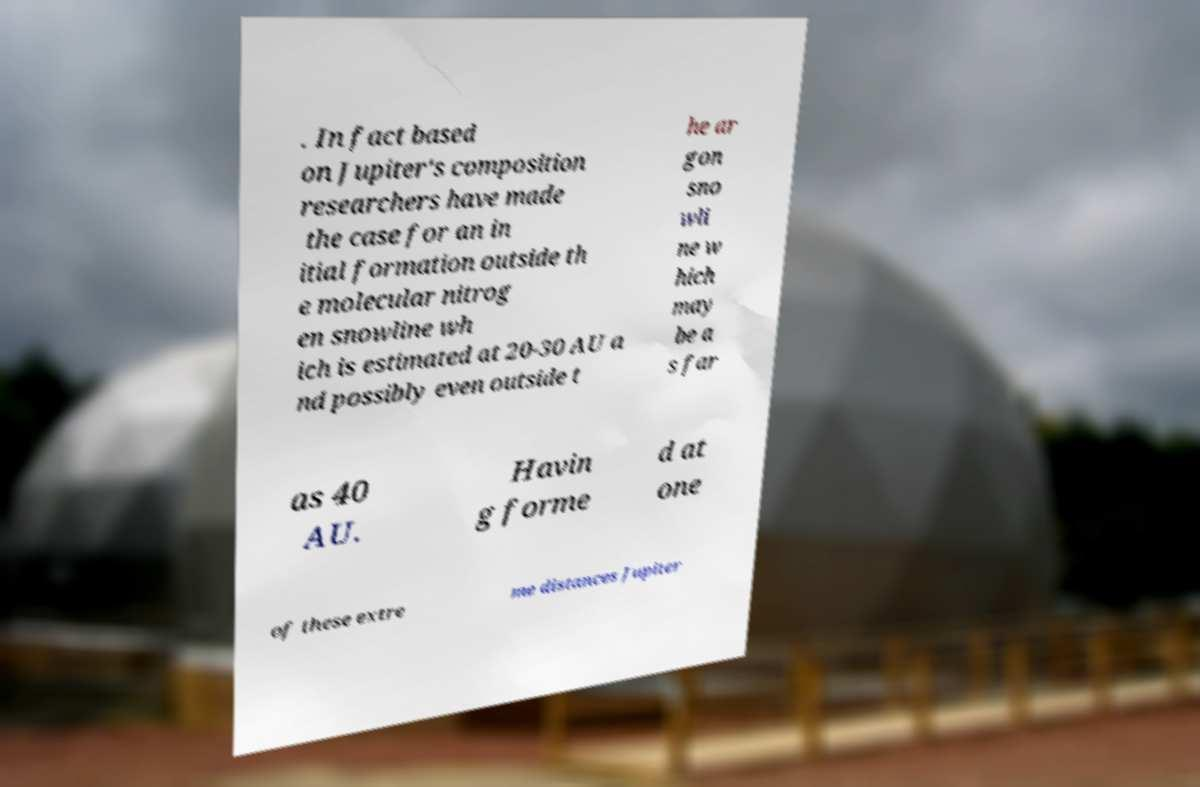Please read and relay the text visible in this image. What does it say? . In fact based on Jupiter's composition researchers have made the case for an in itial formation outside th e molecular nitrog en snowline wh ich is estimated at 20-30 AU a nd possibly even outside t he ar gon sno wli ne w hich may be a s far as 40 AU. Havin g forme d at one of these extre me distances Jupiter 